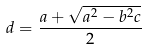<formula> <loc_0><loc_0><loc_500><loc_500>d = \frac { a + \sqrt { a ^ { 2 } - b ^ { 2 } c } } { 2 }</formula> 